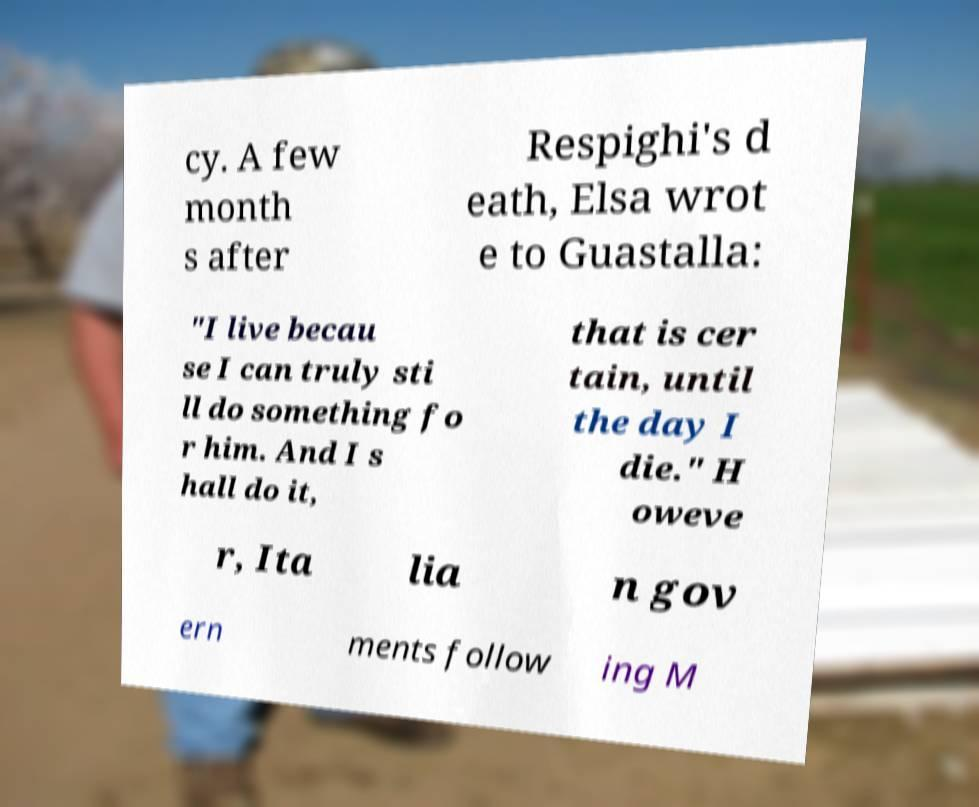Could you extract and type out the text from this image? cy. A few month s after Respighi's d eath, Elsa wrot e to Guastalla: "I live becau se I can truly sti ll do something fo r him. And I s hall do it, that is cer tain, until the day I die." H oweve r, Ita lia n gov ern ments follow ing M 